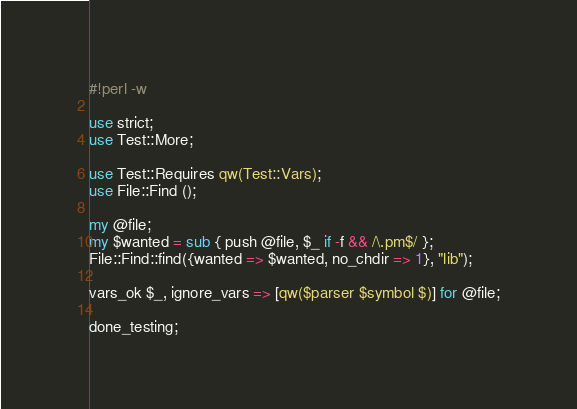Convert code to text. <code><loc_0><loc_0><loc_500><loc_500><_Perl_>#!perl -w

use strict;
use Test::More;

use Test::Requires qw(Test::Vars);
use File::Find ();

my @file;
my $wanted = sub { push @file, $_ if -f && /\.pm$/ };
File::Find::find({wanted => $wanted, no_chdir => 1}, "lib");

vars_ok $_, ignore_vars => [qw($parser $symbol $)] for @file;

done_testing;
</code> 